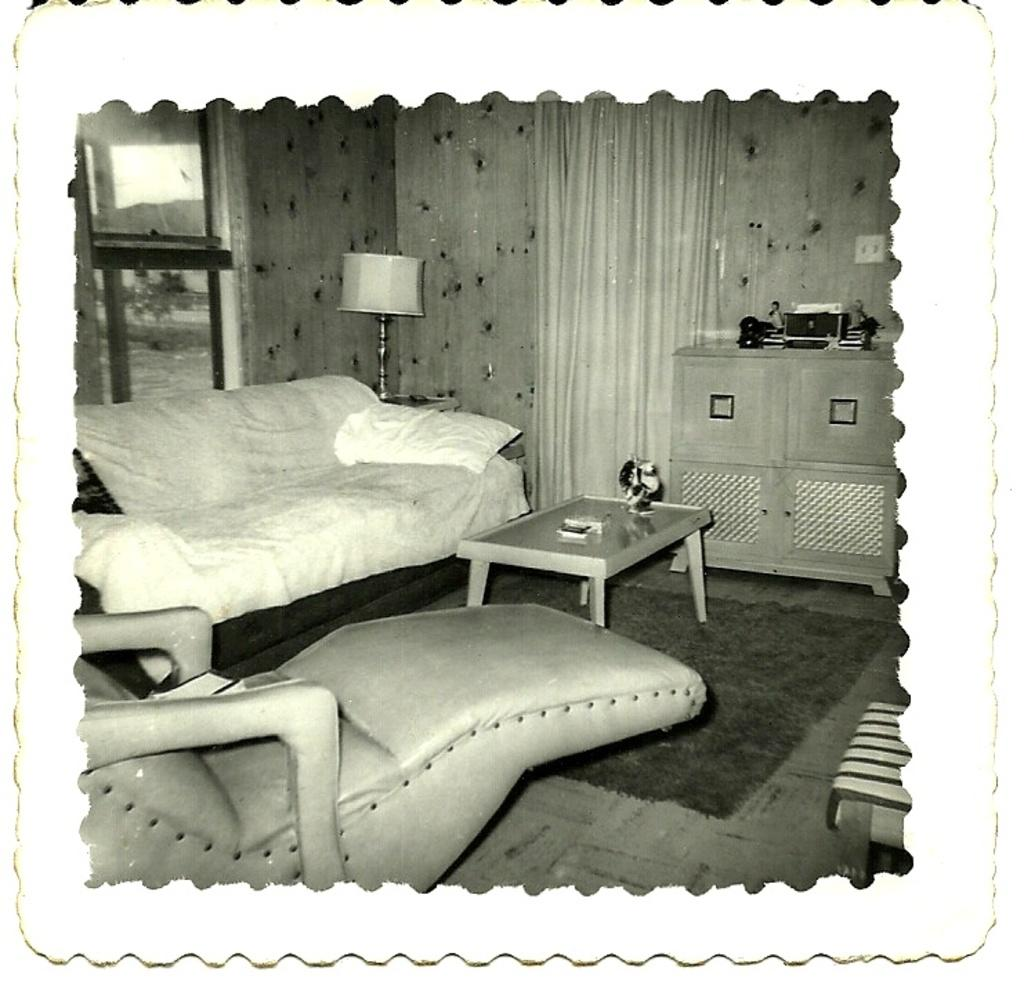What type of furniture is present in the image? There is a sofa set and a table in the image. What can be seen in the background of the image? There is a lamp and a curtain associated with a wall in the background of the image. How many goldfish are swimming in the bowl on the table in the image? There is no bowl or goldfish present on the table in the image. What type of match can be seen being used to light the lamp in the image? There is no match or lighting activity depicted in the image; the lamp is already lit. 